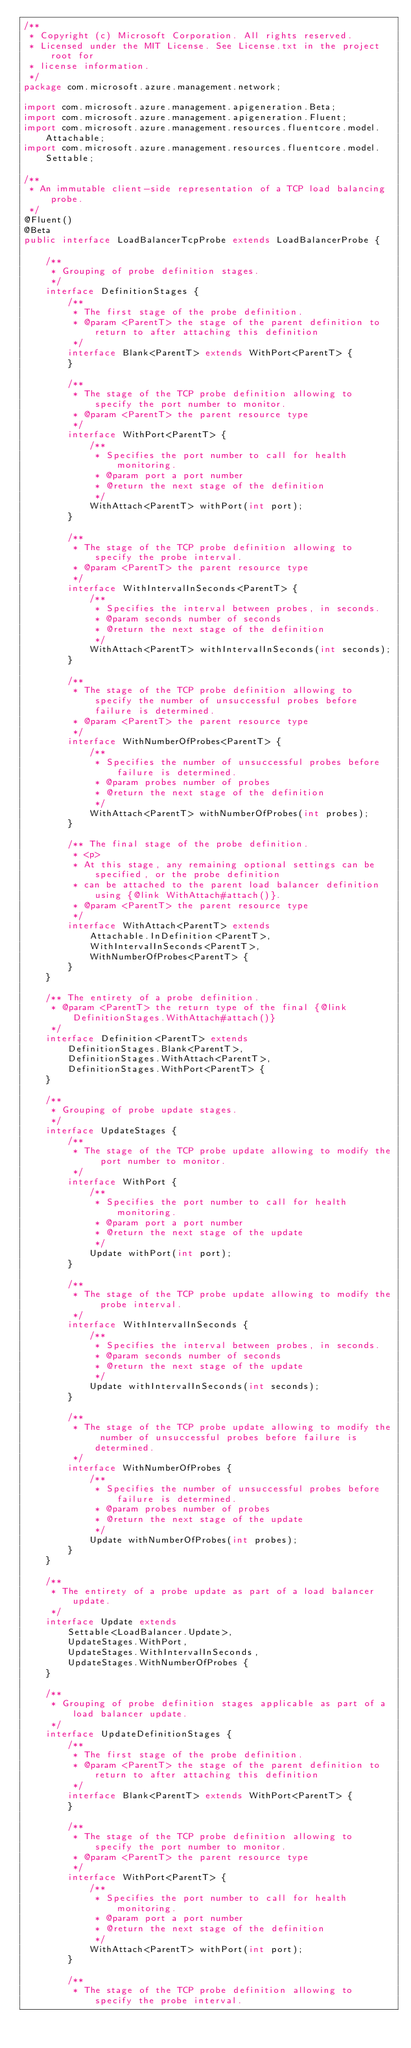<code> <loc_0><loc_0><loc_500><loc_500><_Java_>/**
 * Copyright (c) Microsoft Corporation. All rights reserved.
 * Licensed under the MIT License. See License.txt in the project root for
 * license information.
 */
package com.microsoft.azure.management.network;

import com.microsoft.azure.management.apigeneration.Beta;
import com.microsoft.azure.management.apigeneration.Fluent;
import com.microsoft.azure.management.resources.fluentcore.model.Attachable;
import com.microsoft.azure.management.resources.fluentcore.model.Settable;

/**
 * An immutable client-side representation of a TCP load balancing probe.
 */
@Fluent()
@Beta
public interface LoadBalancerTcpProbe extends LoadBalancerProbe {

    /**
     * Grouping of probe definition stages.
     */
    interface DefinitionStages {
        /**
         * The first stage of the probe definition.
         * @param <ParentT> the stage of the parent definition to return to after attaching this definition
         */
        interface Blank<ParentT> extends WithPort<ParentT> {
        }

        /**
         * The stage of the TCP probe definition allowing to specify the port number to monitor.
         * @param <ParentT> the parent resource type
         */
        interface WithPort<ParentT> {
            /**
             * Specifies the port number to call for health monitoring.
             * @param port a port number
             * @return the next stage of the definition
             */
            WithAttach<ParentT> withPort(int port);
        }

        /**
         * The stage of the TCP probe definition allowing to specify the probe interval.
         * @param <ParentT> the parent resource type
         */
        interface WithIntervalInSeconds<ParentT> {
            /**
             * Specifies the interval between probes, in seconds.
             * @param seconds number of seconds
             * @return the next stage of the definition
             */
            WithAttach<ParentT> withIntervalInSeconds(int seconds);
        }

        /**
         * The stage of the TCP probe definition allowing to specify the number of unsuccessful probes before failure is determined.
         * @param <ParentT> the parent resource type
         */
        interface WithNumberOfProbes<ParentT> {
            /**
             * Specifies the number of unsuccessful probes before failure is determined.
             * @param probes number of probes
             * @return the next stage of the definition
             */
            WithAttach<ParentT> withNumberOfProbes(int probes);
        }

        /** The final stage of the probe definition.
         * <p>
         * At this stage, any remaining optional settings can be specified, or the probe definition
         * can be attached to the parent load balancer definition using {@link WithAttach#attach()}.
         * @param <ParentT> the parent resource type
         */
        interface WithAttach<ParentT> extends
            Attachable.InDefinition<ParentT>,
            WithIntervalInSeconds<ParentT>,
            WithNumberOfProbes<ParentT> {
        }
    }

    /** The entirety of a probe definition.
     * @param <ParentT> the return type of the final {@link DefinitionStages.WithAttach#attach()}
     */
    interface Definition<ParentT> extends
        DefinitionStages.Blank<ParentT>,
        DefinitionStages.WithAttach<ParentT>,
        DefinitionStages.WithPort<ParentT> {
    }

    /**
     * Grouping of probe update stages.
     */
    interface UpdateStages {
        /**
         * The stage of the TCP probe update allowing to modify the port number to monitor.
         */
        interface WithPort {
            /**
             * Specifies the port number to call for health monitoring.
             * @param port a port number
             * @return the next stage of the update
             */
            Update withPort(int port);
        }

        /**
         * The stage of the TCP probe update allowing to modify the probe interval.
         */
        interface WithIntervalInSeconds {
            /**
             * Specifies the interval between probes, in seconds.
             * @param seconds number of seconds
             * @return the next stage of the update
             */
            Update withIntervalInSeconds(int seconds);
        }

        /**
         * The stage of the TCP probe update allowing to modify the number of unsuccessful probes before failure is determined.
         */
        interface WithNumberOfProbes {
            /**
             * Specifies the number of unsuccessful probes before failure is determined.
             * @param probes number of probes
             * @return the next stage of the update
             */
            Update withNumberOfProbes(int probes);
        }
    }

    /**
     * The entirety of a probe update as part of a load balancer update.
     */
    interface Update extends
        Settable<LoadBalancer.Update>,
        UpdateStages.WithPort,
        UpdateStages.WithIntervalInSeconds,
        UpdateStages.WithNumberOfProbes {
    }

    /**
     * Grouping of probe definition stages applicable as part of a load balancer update.
     */
    interface UpdateDefinitionStages {
        /**
         * The first stage of the probe definition.
         * @param <ParentT> the stage of the parent definition to return to after attaching this definition
         */
        interface Blank<ParentT> extends WithPort<ParentT> {
        }

        /**
         * The stage of the TCP probe definition allowing to specify the port number to monitor.
         * @param <ParentT> the parent resource type
         */
        interface WithPort<ParentT> {
            /**
             * Specifies the port number to call for health monitoring.
             * @param port a port number
             * @return the next stage of the definition
             */
            WithAttach<ParentT> withPort(int port);
        }

        /**
         * The stage of the TCP probe definition allowing to specify the probe interval.</code> 